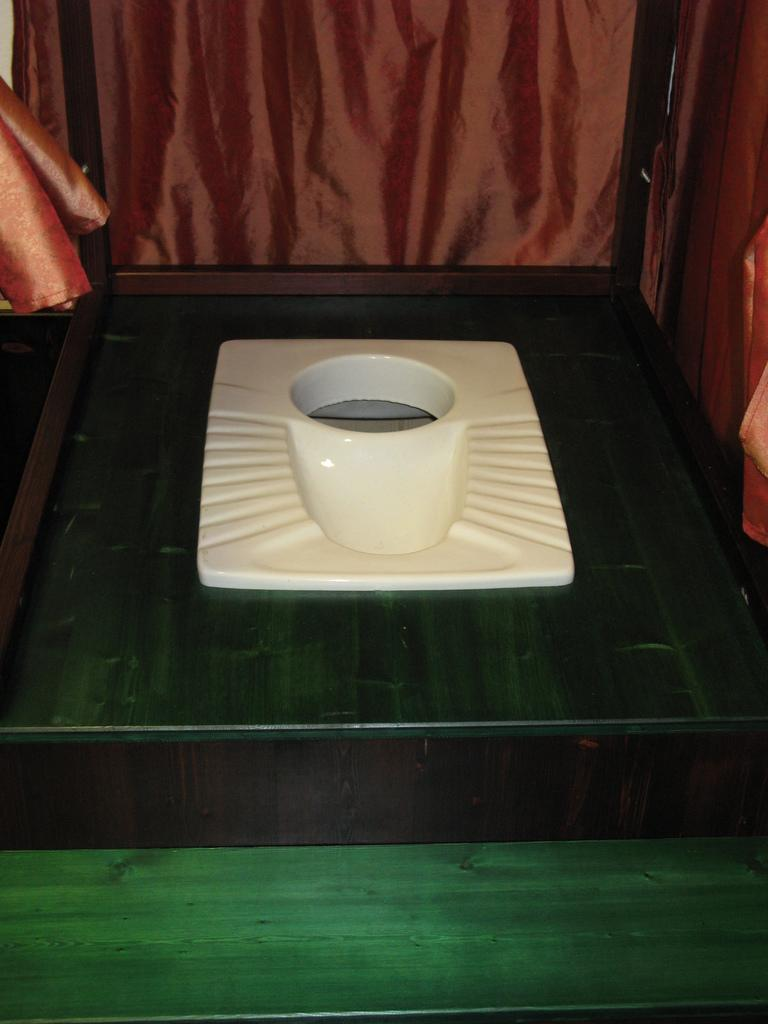What is the main object on the wooden surface in the image? There is a toilet on a wooden surface in the image. What else can be seen in the image besides the toilet? There are two cloths in the image, one truncated towards the left and the other towards the right. Can you tell me how the doll is breathing in the image? There is no doll present in the image, so it is not possible to determine how a doll might be breathing. 